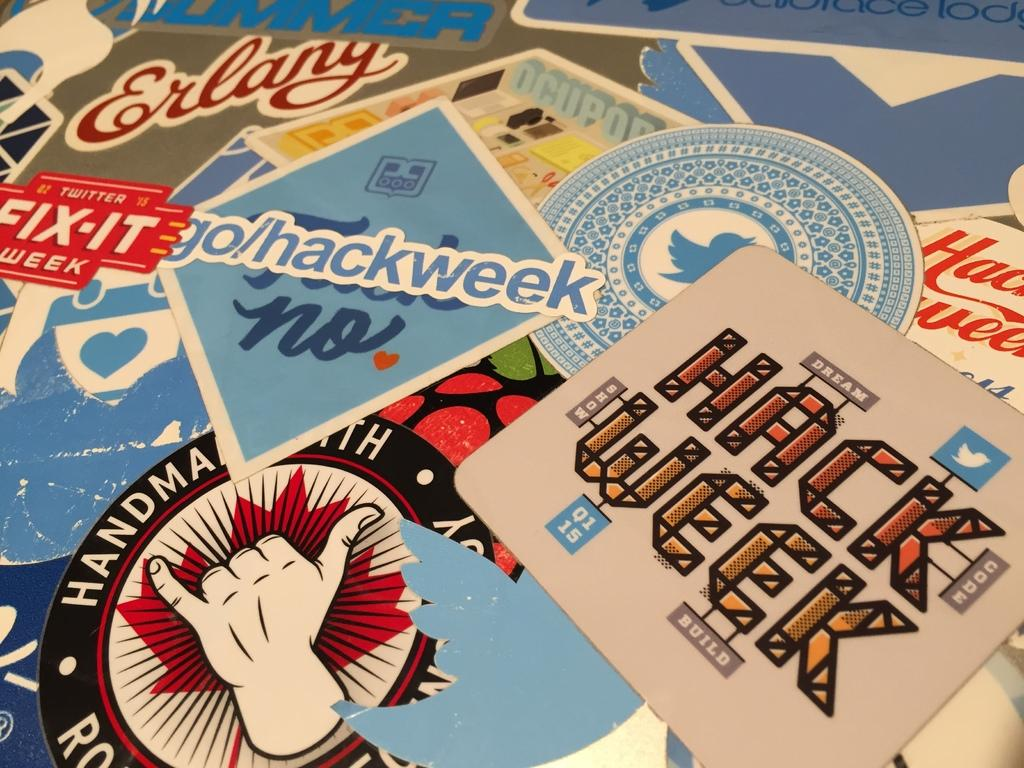What can be seen in the center of the image? There are posts in the center of the image. What is on one of the posts? There is a poster on one of the posts. What is depicted on the poster? The poster has an image of a human hand. What else is on the poster besides the image? There is writing on the poster. How much money is being exchanged between the hands on the poster? There is no money being exchanged in the image, as the poster only features an image of a human hand and writing. Is there a coat hanging on one of the posts? There is no coat present in the image; it only contains posts, a poster, and writing. 